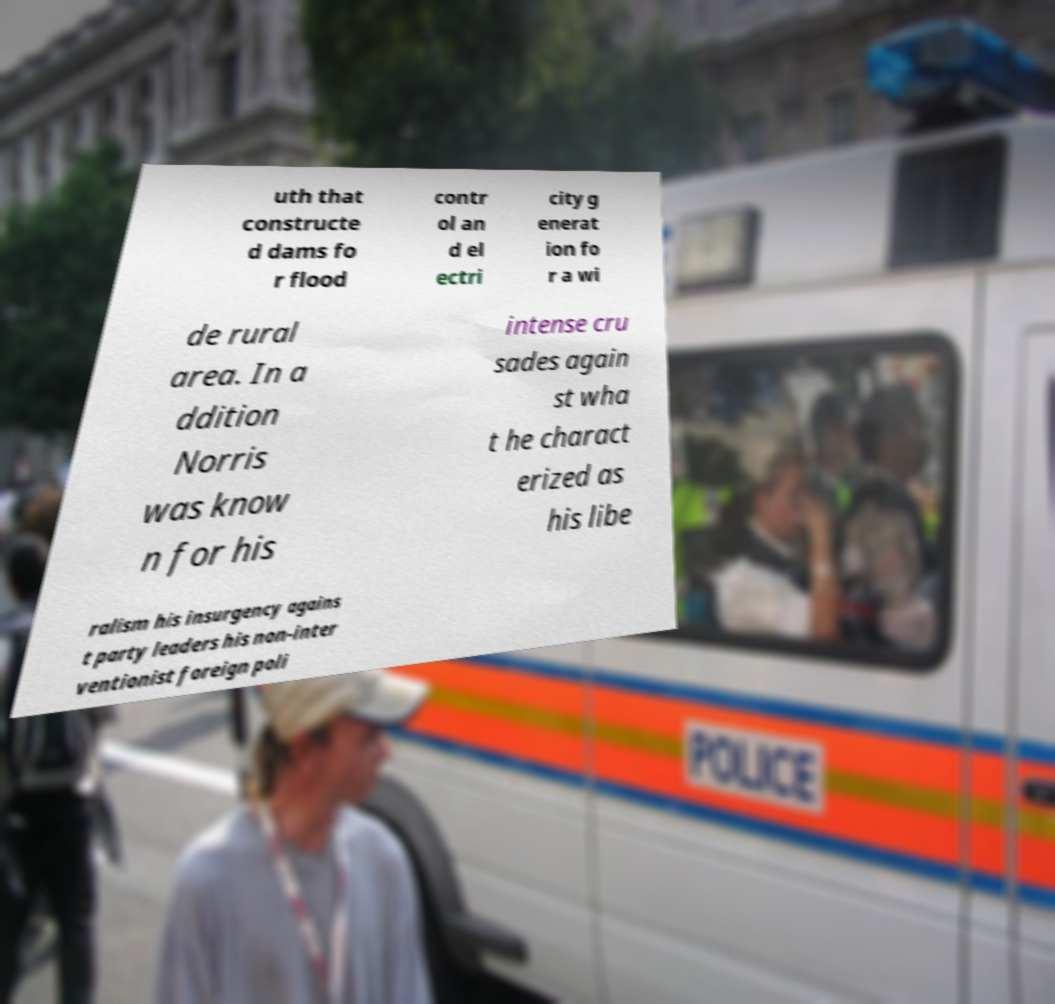I need the written content from this picture converted into text. Can you do that? uth that constructe d dams fo r flood contr ol an d el ectri city g enerat ion fo r a wi de rural area. In a ddition Norris was know n for his intense cru sades again st wha t he charact erized as his libe ralism his insurgency agains t party leaders his non-inter ventionist foreign poli 